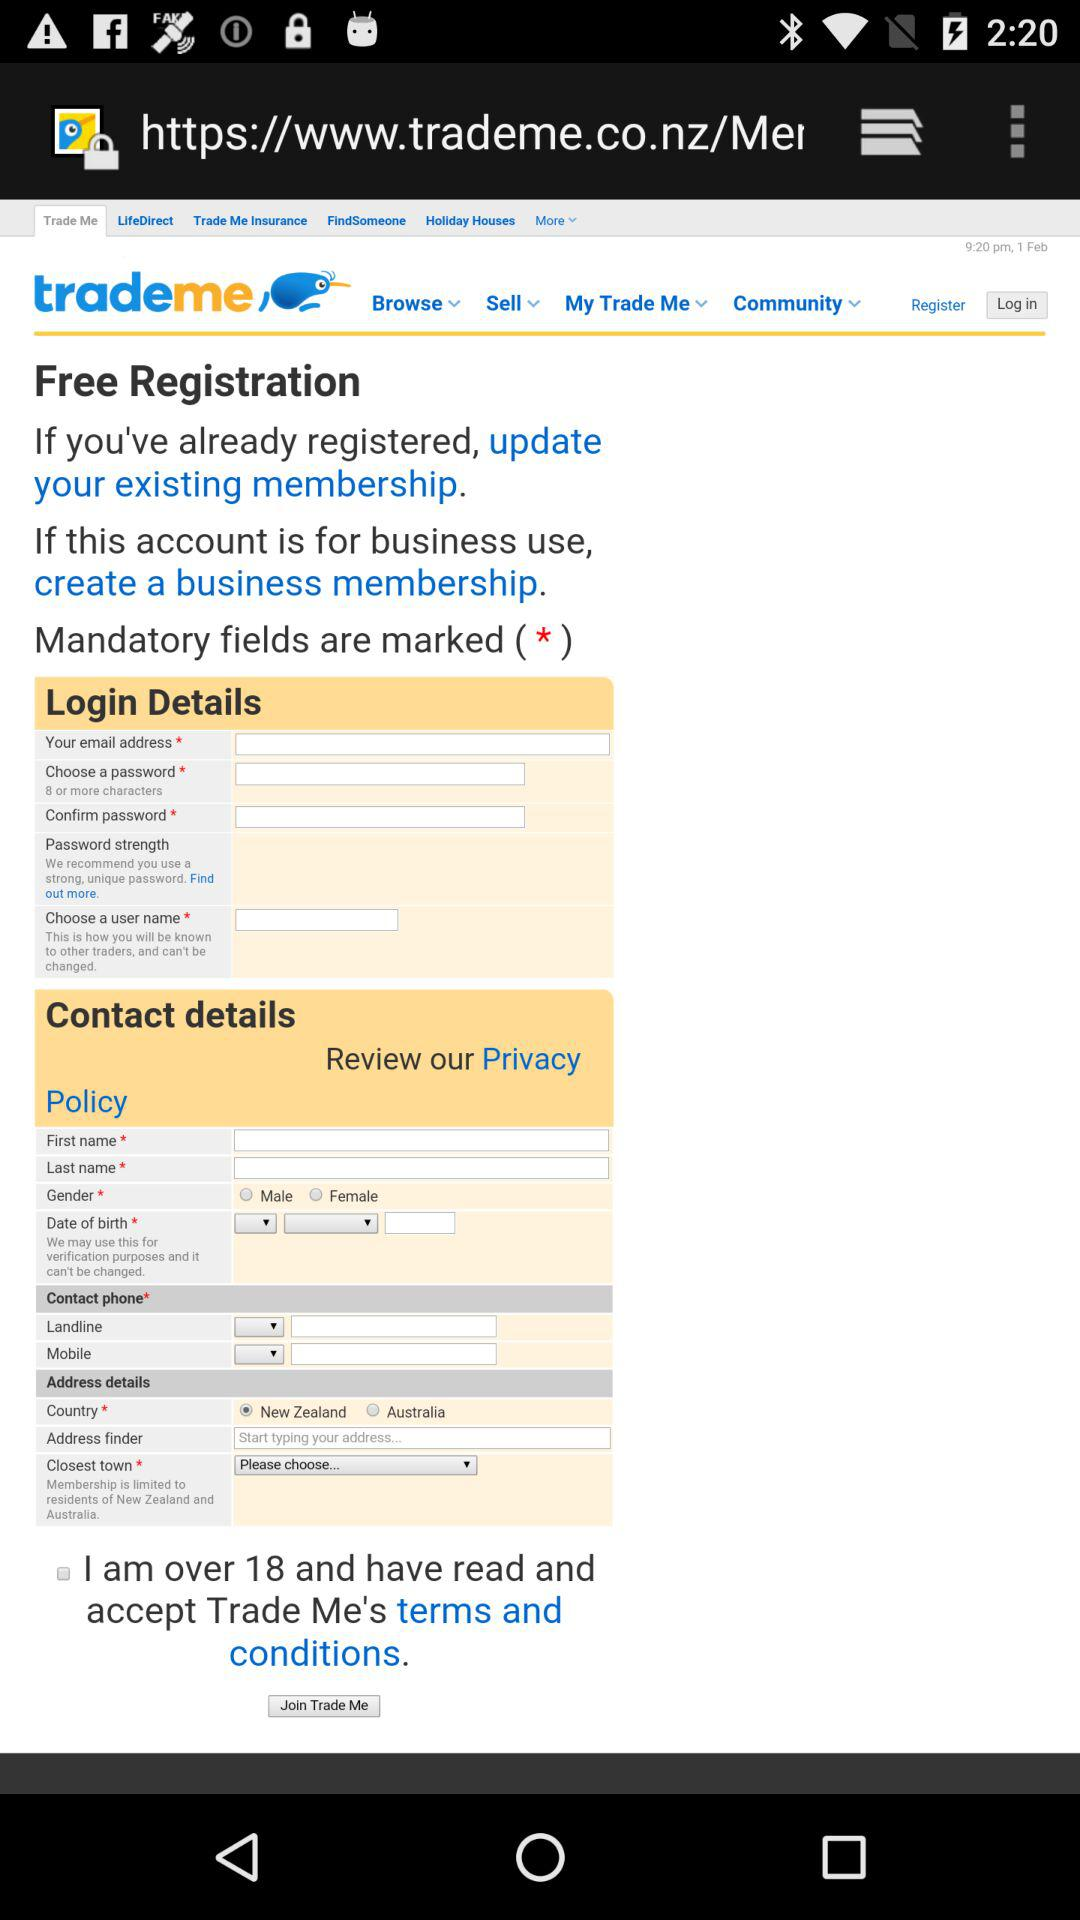Which country name is selected? The selected country name is New Zealand. 